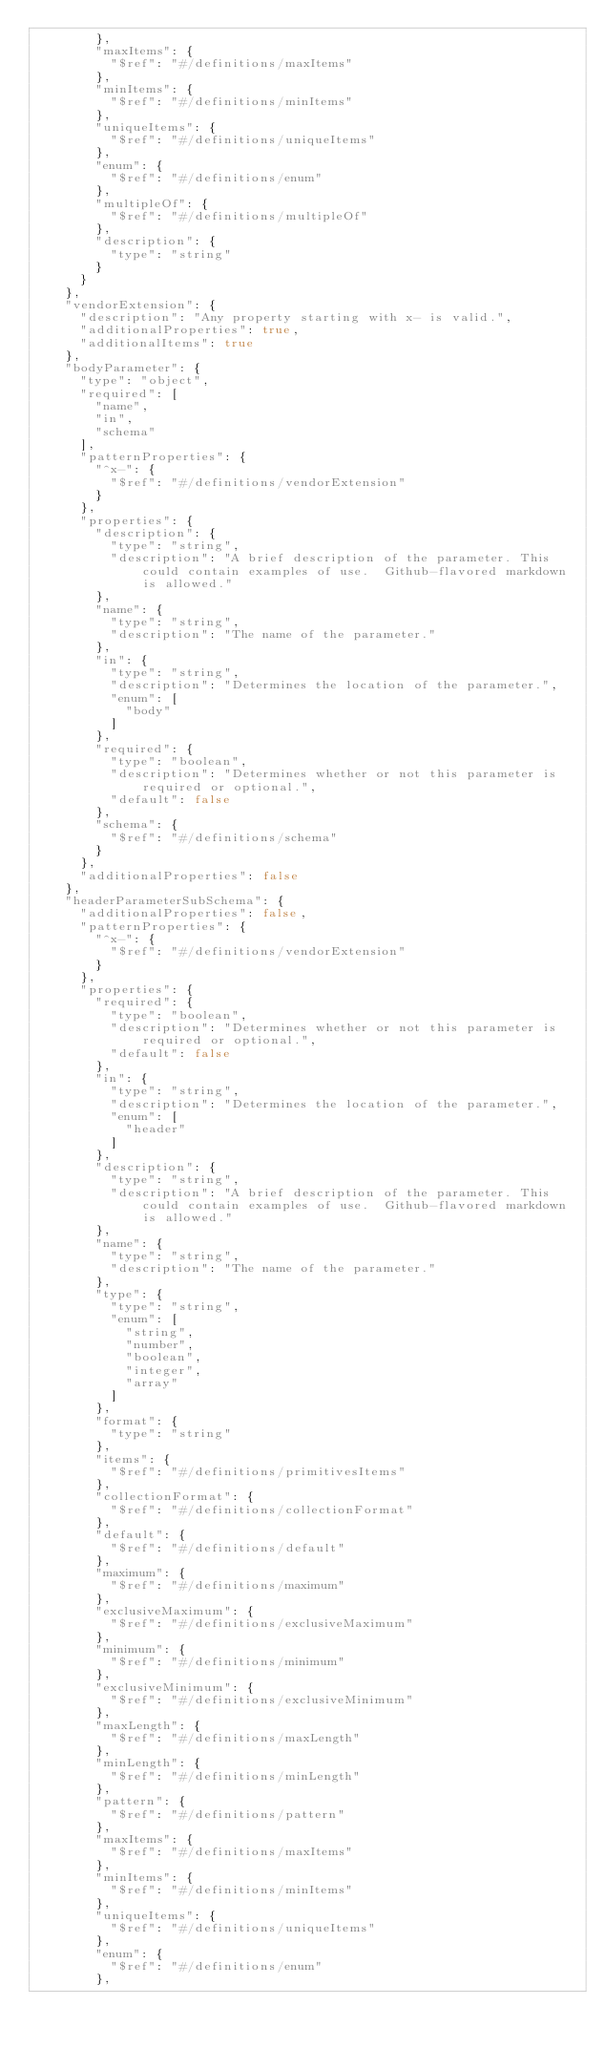<code> <loc_0><loc_0><loc_500><loc_500><_JavaScript_>        },
        "maxItems": {
          "$ref": "#/definitions/maxItems"
        },
        "minItems": {
          "$ref": "#/definitions/minItems"
        },
        "uniqueItems": {
          "$ref": "#/definitions/uniqueItems"
        },
        "enum": {
          "$ref": "#/definitions/enum"
        },
        "multipleOf": {
          "$ref": "#/definitions/multipleOf"
        },
        "description": {
          "type": "string"
        }
      }
    },
    "vendorExtension": {
      "description": "Any property starting with x- is valid.",
      "additionalProperties": true,
      "additionalItems": true
    },
    "bodyParameter": {
      "type": "object",
      "required": [
        "name",
        "in",
        "schema"
      ],
      "patternProperties": {
        "^x-": {
          "$ref": "#/definitions/vendorExtension"
        }
      },
      "properties": {
        "description": {
          "type": "string",
          "description": "A brief description of the parameter. This could contain examples of use.  Github-flavored markdown is allowed."
        },
        "name": {
          "type": "string",
          "description": "The name of the parameter."
        },
        "in": {
          "type": "string",
          "description": "Determines the location of the parameter.",
          "enum": [
            "body"
          ]
        },
        "required": {
          "type": "boolean",
          "description": "Determines whether or not this parameter is required or optional.",
          "default": false
        },
        "schema": {
          "$ref": "#/definitions/schema"
        }
      },
      "additionalProperties": false
    },
    "headerParameterSubSchema": {
      "additionalProperties": false,
      "patternProperties": {
        "^x-": {
          "$ref": "#/definitions/vendorExtension"
        }
      },
      "properties": {
        "required": {
          "type": "boolean",
          "description": "Determines whether or not this parameter is required or optional.",
          "default": false
        },
        "in": {
          "type": "string",
          "description": "Determines the location of the parameter.",
          "enum": [
            "header"
          ]
        },
        "description": {
          "type": "string",
          "description": "A brief description of the parameter. This could contain examples of use.  Github-flavored markdown is allowed."
        },
        "name": {
          "type": "string",
          "description": "The name of the parameter."
        },
        "type": {
          "type": "string",
          "enum": [
            "string",
            "number",
            "boolean",
            "integer",
            "array"
          ]
        },
        "format": {
          "type": "string"
        },
        "items": {
          "$ref": "#/definitions/primitivesItems"
        },
        "collectionFormat": {
          "$ref": "#/definitions/collectionFormat"
        },
        "default": {
          "$ref": "#/definitions/default"
        },
        "maximum": {
          "$ref": "#/definitions/maximum"
        },
        "exclusiveMaximum": {
          "$ref": "#/definitions/exclusiveMaximum"
        },
        "minimum": {
          "$ref": "#/definitions/minimum"
        },
        "exclusiveMinimum": {
          "$ref": "#/definitions/exclusiveMinimum"
        },
        "maxLength": {
          "$ref": "#/definitions/maxLength"
        },
        "minLength": {
          "$ref": "#/definitions/minLength"
        },
        "pattern": {
          "$ref": "#/definitions/pattern"
        },
        "maxItems": {
          "$ref": "#/definitions/maxItems"
        },
        "minItems": {
          "$ref": "#/definitions/minItems"
        },
        "uniqueItems": {
          "$ref": "#/definitions/uniqueItems"
        },
        "enum": {
          "$ref": "#/definitions/enum"
        },</code> 